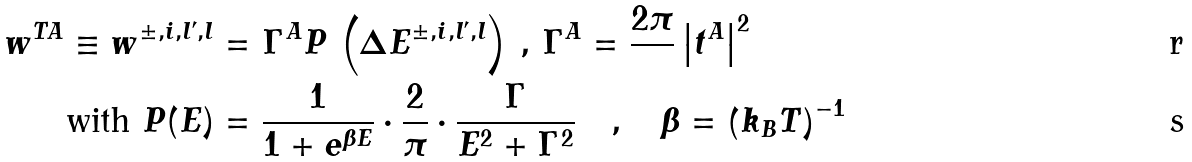<formula> <loc_0><loc_0><loc_500><loc_500>w ^ { T A } \equiv w ^ { \pm , i , l ^ { \prime } , l } & = \Gamma ^ { A } P \, \left ( \Delta E ^ { \pm , i , l ^ { \prime } , l } \right ) \, , \, \Gamma ^ { A } = \frac { 2 \pi } { } \left | t ^ { A } \right | ^ { 2 } \\ \text { with } P ( E ) & = \frac { 1 } { 1 + e ^ { \beta E } } \cdot \frac { 2 } { \pi } \cdot \frac { \Gamma } { E ^ { 2 } + \Gamma ^ { 2 } } \quad , \quad \beta = \left ( k _ { B } T \right ) ^ { - 1 }</formula> 